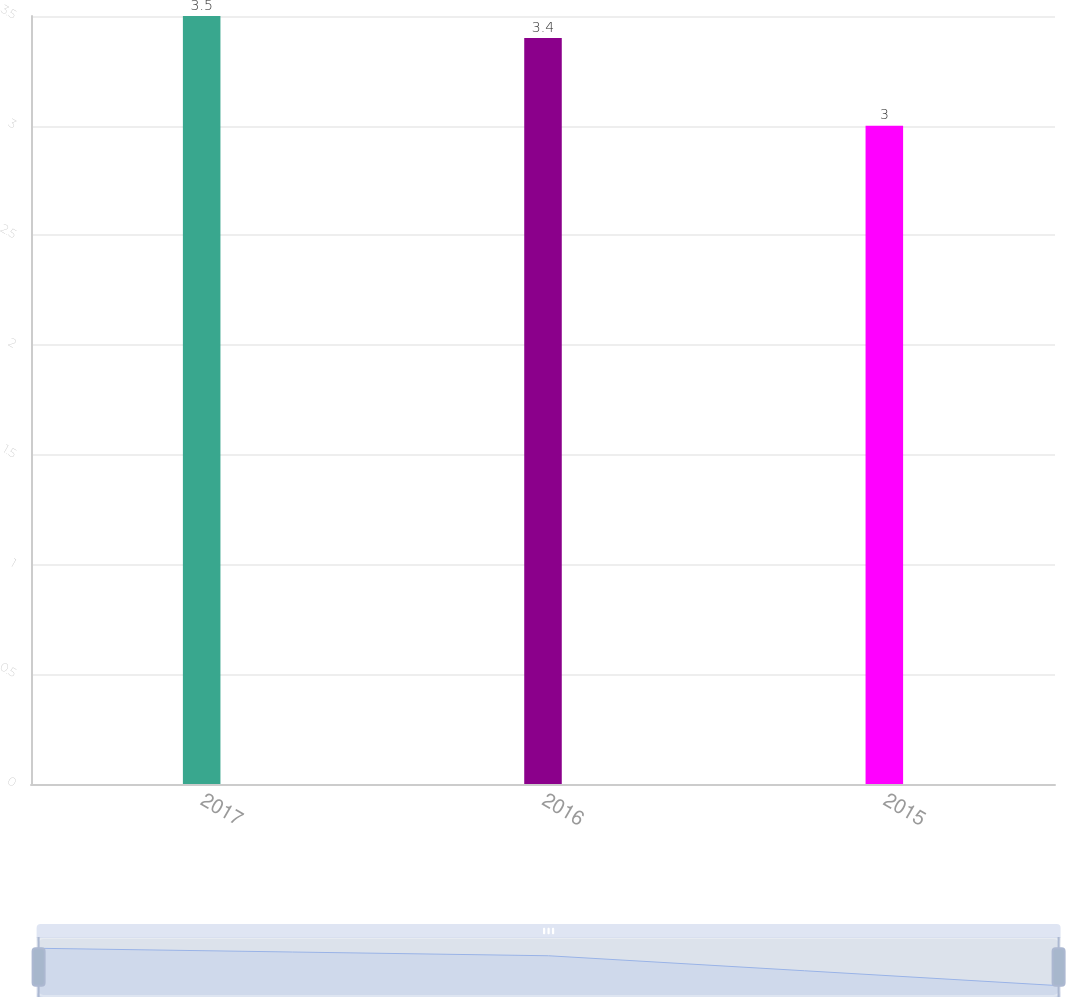Convert chart. <chart><loc_0><loc_0><loc_500><loc_500><bar_chart><fcel>2017<fcel>2016<fcel>2015<nl><fcel>3.5<fcel>3.4<fcel>3<nl></chart> 